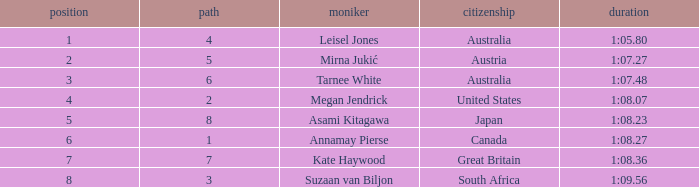What is the Nationality of the Swimmer in Lane 4 or larger with a Rank of 5 or more? Great Britain. 